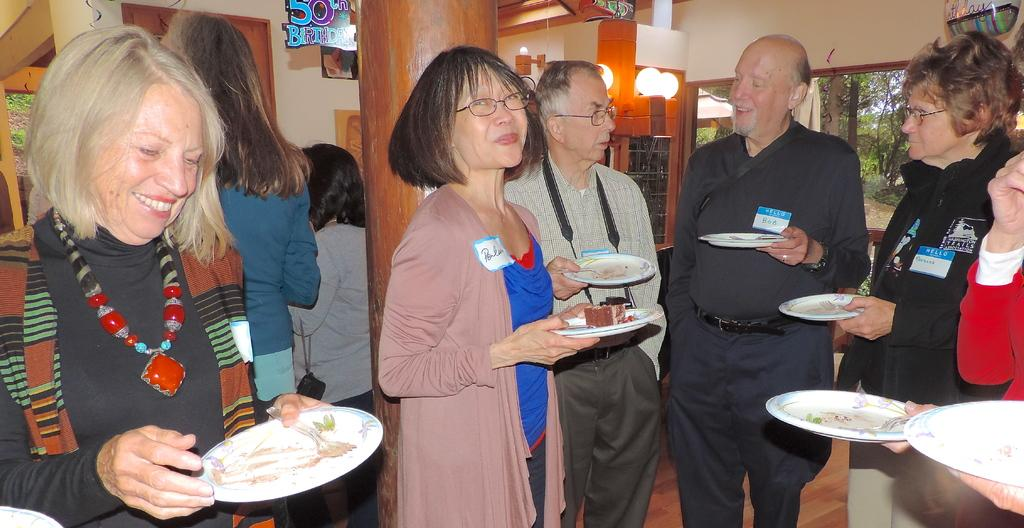How many groups of people can be seen in the image? There are two groups of people in the image, one on the right side and one on the left side. What is visible in the background of the image? There are windows on the right side of the image, in the background area. What type of needle is being used by the people in the image? There is no needle present in the image; it features people on both sides and windows in the background. 